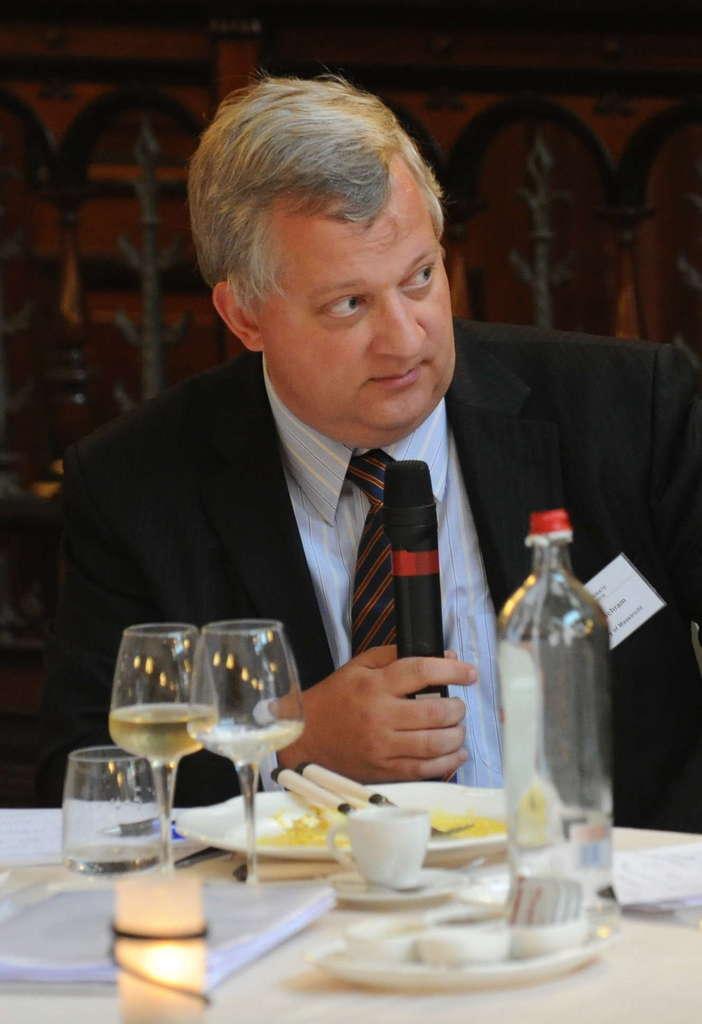In one or two sentences, can you explain what this image depicts? In this image in the center there is one man who is sitting and he is holding a mike in front of him there is one table on the table there are bottles, glasses, plates, and one cup and spoons are there on the table. 